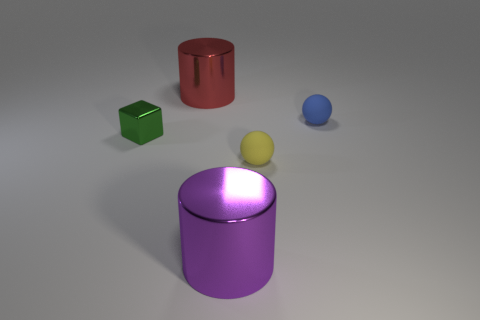Add 4 big cyan shiny blocks. How many objects exist? 9 Subtract all balls. How many objects are left? 3 Subtract 0 red blocks. How many objects are left? 5 Subtract all small matte balls. Subtract all green cubes. How many objects are left? 2 Add 1 large shiny cylinders. How many large shiny cylinders are left? 3 Add 3 small yellow rubber spheres. How many small yellow rubber spheres exist? 4 